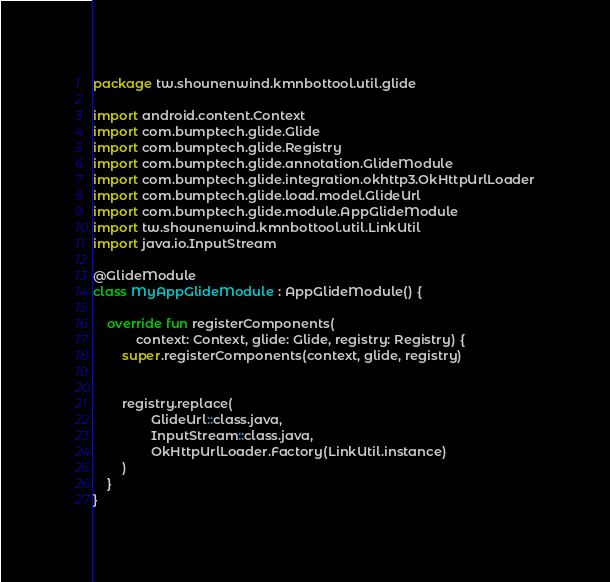Convert code to text. <code><loc_0><loc_0><loc_500><loc_500><_Kotlin_>package tw.shounenwind.kmnbottool.util.glide

import android.content.Context
import com.bumptech.glide.Glide
import com.bumptech.glide.Registry
import com.bumptech.glide.annotation.GlideModule
import com.bumptech.glide.integration.okhttp3.OkHttpUrlLoader
import com.bumptech.glide.load.model.GlideUrl
import com.bumptech.glide.module.AppGlideModule
import tw.shounenwind.kmnbottool.util.LinkUtil
import java.io.InputStream

@GlideModule
class MyAppGlideModule : AppGlideModule() {

    override fun registerComponents(
            context: Context, glide: Glide, registry: Registry) {
        super.registerComponents(context, glide, registry)


        registry.replace(
                GlideUrl::class.java,
                InputStream::class.java,
                OkHttpUrlLoader.Factory(LinkUtil.instance)
        )
    }
}</code> 